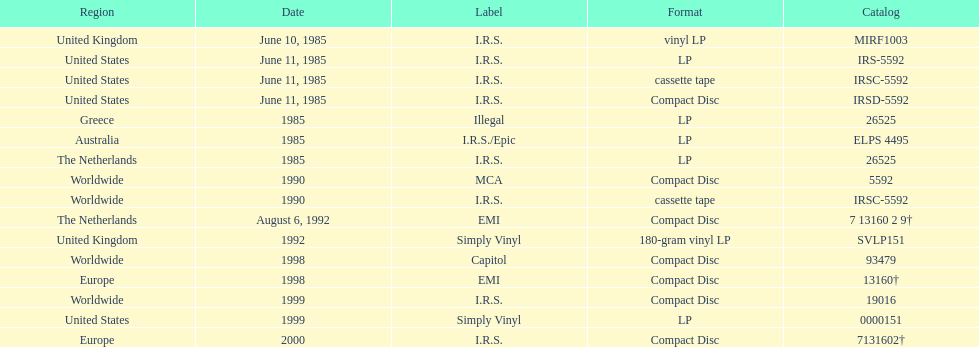In which sole region is the vinyl lp format available? United Kingdom. 